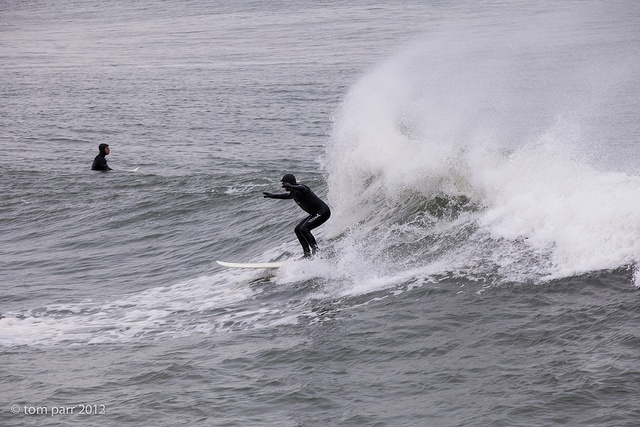Describe the objects in this image and their specific colors. I can see people in gray, black, and darkgray tones, surfboard in gray, lightgray, and darkgray tones, people in gray, black, maroon, and darkgray tones, and surfboard in lightgray, darkgray, and gray tones in this image. 